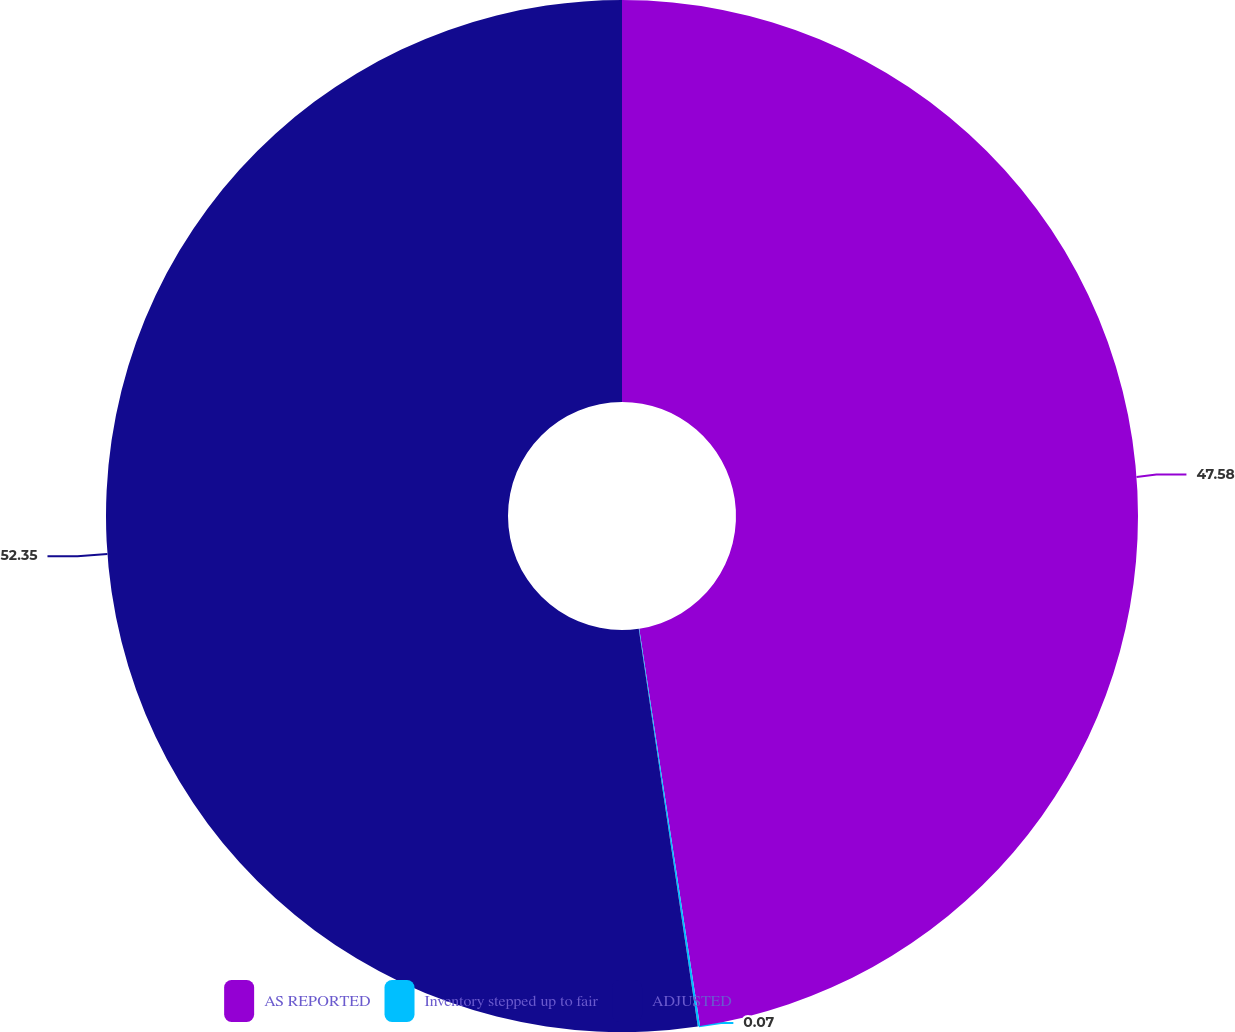Convert chart. <chart><loc_0><loc_0><loc_500><loc_500><pie_chart><fcel>AS REPORTED<fcel>Inventory stepped up to fair<fcel>ADJUSTED<nl><fcel>47.58%<fcel>0.07%<fcel>52.34%<nl></chart> 